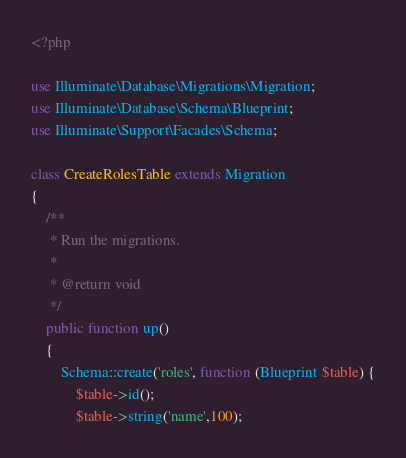Convert code to text. <code><loc_0><loc_0><loc_500><loc_500><_PHP_><?php

use Illuminate\Database\Migrations\Migration;
use Illuminate\Database\Schema\Blueprint;
use Illuminate\Support\Facades\Schema;

class CreateRolesTable extends Migration
{
    /**
     * Run the migrations.
     *
     * @return void
     */
    public function up()
    {
        Schema::create('roles', function (Blueprint $table) {
            $table->id();
            $table->string('name',100);</code> 